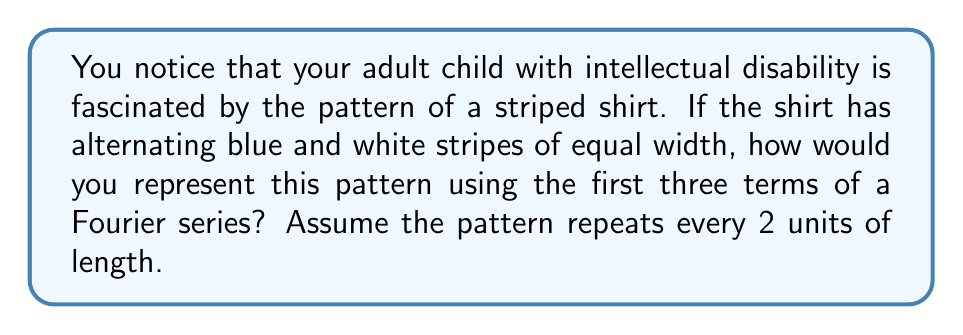What is the answer to this math problem? Let's approach this step-by-step:

1) The pattern of alternating blue and white stripes can be represented as a square wave function. Let's define the function $f(x)$ as:

   $f(x) = \begin{cases} 
   1, & \text{for blue stripes} \\
   -1, & \text{for white stripes}
   \end{cases}$

2) The general form of a Fourier series is:

   $f(x) = \frac{a_0}{2} + \sum_{n=1}^{\infty} (a_n \cos(\frac{n\pi x}{L}) + b_n \sin(\frac{n\pi x}{L}))$

   Where $L$ is half the period of the function. In our case, $L = 1$ as the pattern repeats every 2 units.

3) For a square wave, all even terms are zero, and $a_0 = 0$. The non-zero terms are:

   $b_n = \frac{4}{\pi n}$ for odd $n$

4) Therefore, the first three non-zero terms of the Fourier series are:

   $f(x) \approx \frac{4}{\pi} \sin(\pi x) + \frac{4}{3\pi} \sin(3\pi x) + \frac{4}{5\pi} \sin(5\pi x)$

5) This approximation represents the striped pattern, with the first term giving the primary shape and subsequent terms refining the edges to make them sharper.
Answer: $f(x) \approx \frac{4}{\pi} \sin(\pi x) + \frac{4}{3\pi} \sin(3\pi x) + \frac{4}{5\pi} \sin(5\pi x)$ 